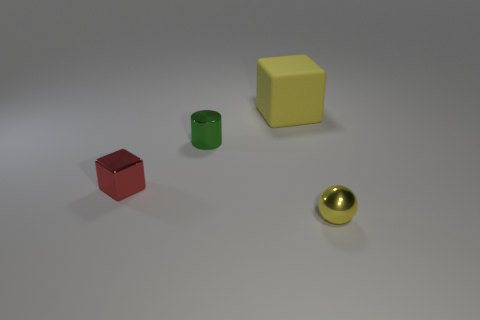What is the material of the other object that is the same shape as the red metallic object?
Offer a very short reply. Rubber. Are there an equal number of green shiny objects that are on the right side of the big thing and big gray things?
Your response must be concise. Yes. What is the color of the small object that is in front of the red thing?
Provide a short and direct response. Yellow. What number of other things are the same color as the tiny sphere?
Your response must be concise. 1. Is there anything else that is the same size as the rubber block?
Provide a short and direct response. No. Does the shiny object that is right of the rubber thing have the same size as the tiny green metallic cylinder?
Your answer should be compact. Yes. What is the material of the block to the right of the green metallic cylinder?
Keep it short and to the point. Rubber. Is there any other thing that has the same shape as the green metal object?
Provide a short and direct response. No. How many metal things are red objects or blocks?
Your response must be concise. 1. Is the number of green cylinders that are on the left side of the yellow sphere less than the number of shiny objects?
Provide a short and direct response. Yes. 